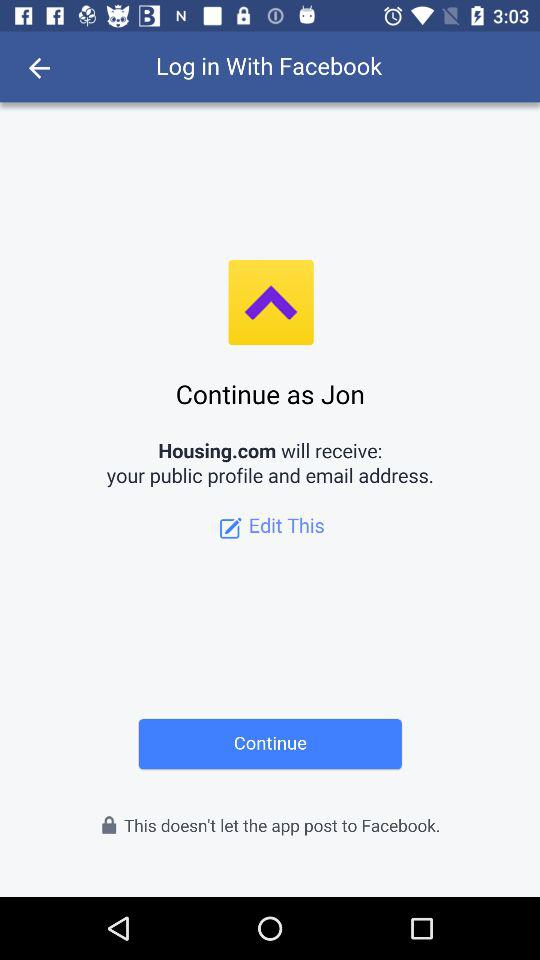What application is asking for permission? The application is "Housing.com". 